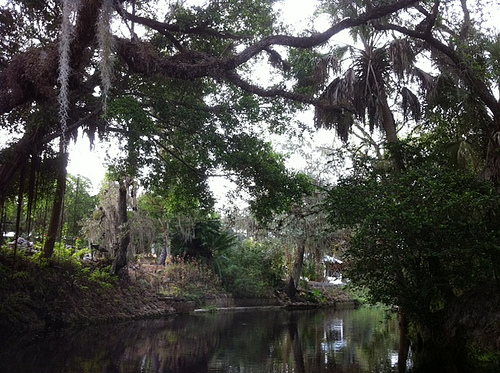<image>
Can you confirm if the water is on the gazebo? No. The water is not positioned on the gazebo. They may be near each other, but the water is not supported by or resting on top of the gazebo. 